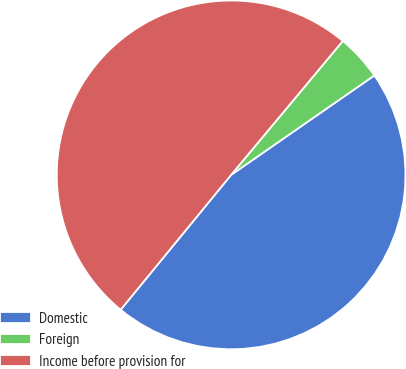Convert chart to OTSL. <chart><loc_0><loc_0><loc_500><loc_500><pie_chart><fcel>Domestic<fcel>Foreign<fcel>Income before provision for<nl><fcel>45.58%<fcel>4.28%<fcel>50.14%<nl></chart> 